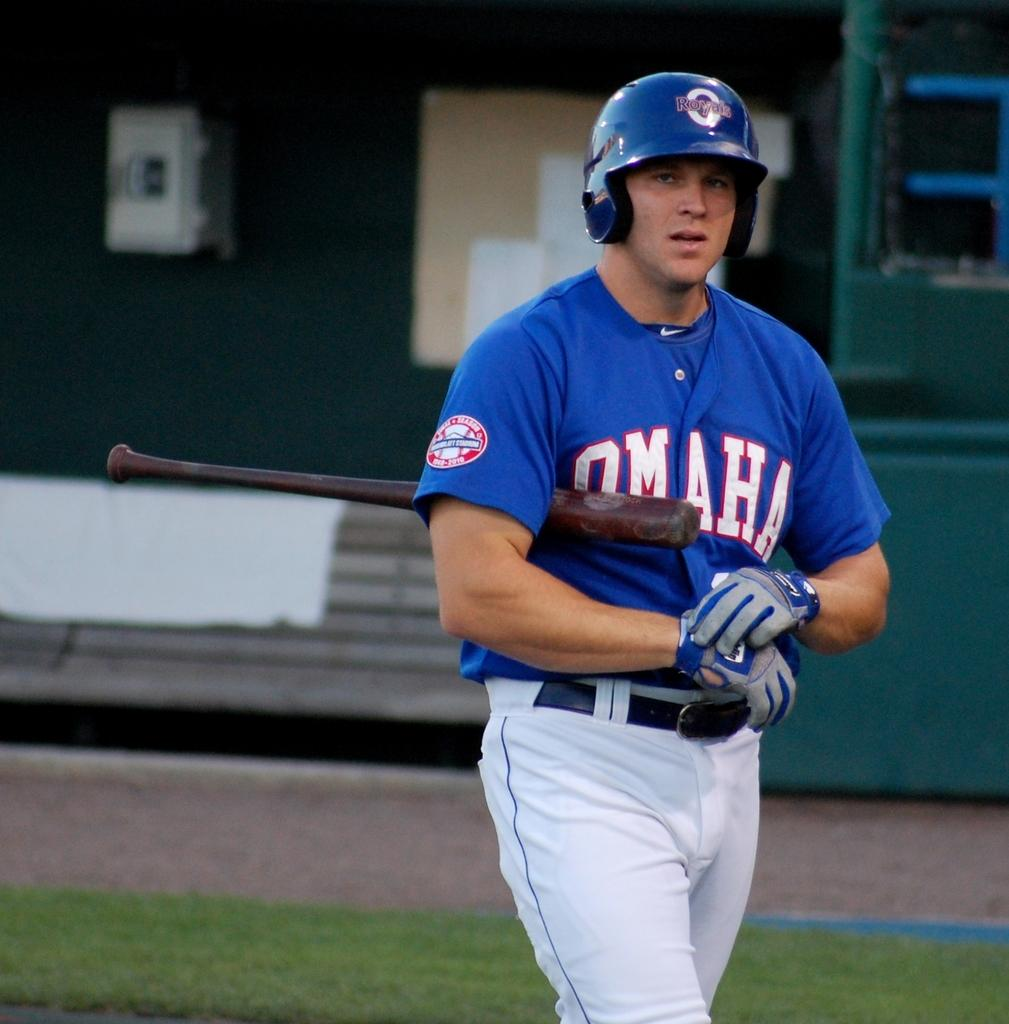Provide a one-sentence caption for the provided image. Baseball player for the Omaha team is walking with a bat on the field. 